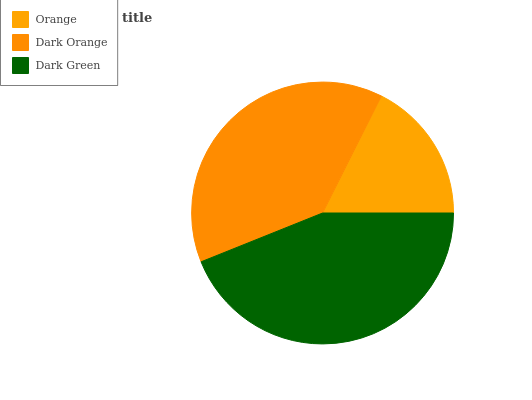Is Orange the minimum?
Answer yes or no. Yes. Is Dark Green the maximum?
Answer yes or no. Yes. Is Dark Orange the minimum?
Answer yes or no. No. Is Dark Orange the maximum?
Answer yes or no. No. Is Dark Orange greater than Orange?
Answer yes or no. Yes. Is Orange less than Dark Orange?
Answer yes or no. Yes. Is Orange greater than Dark Orange?
Answer yes or no. No. Is Dark Orange less than Orange?
Answer yes or no. No. Is Dark Orange the high median?
Answer yes or no. Yes. Is Dark Orange the low median?
Answer yes or no. Yes. Is Orange the high median?
Answer yes or no. No. Is Dark Green the low median?
Answer yes or no. No. 